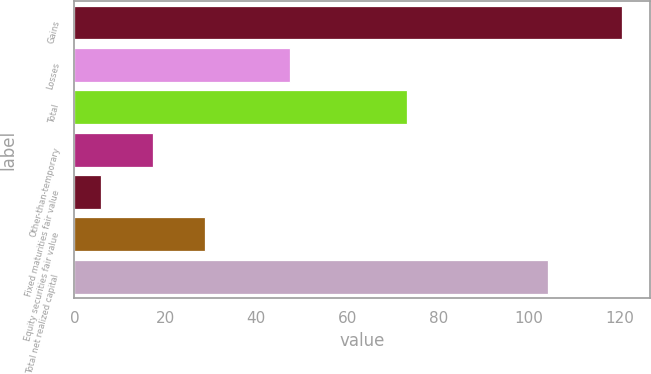Convert chart to OTSL. <chart><loc_0><loc_0><loc_500><loc_500><bar_chart><fcel>Gains<fcel>Losses<fcel>Total<fcel>Other-than-temporary<fcel>Fixed maturities fair value<fcel>Equity securities fair value<fcel>Total net realized capital<nl><fcel>120.5<fcel>47.4<fcel>73.2<fcel>17.27<fcel>5.8<fcel>28.74<fcel>104.2<nl></chart> 